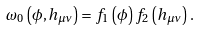<formula> <loc_0><loc_0><loc_500><loc_500>\omega _ { 0 } \left ( \phi , h _ { \mu \nu } \right ) = f _ { 1 } \left ( \phi \right ) f _ { 2 } \left ( h _ { \mu \nu } \right ) .</formula> 